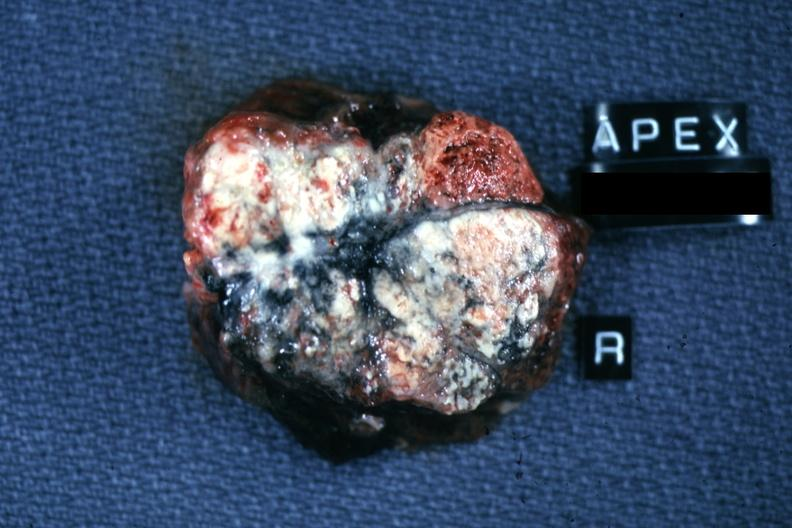what does this image show?
Answer the question using a single word or phrase. Close-up view of nodes with obvious metastatic lesions and anthracotic pigment apparently from apex right lung apparently lung primary 